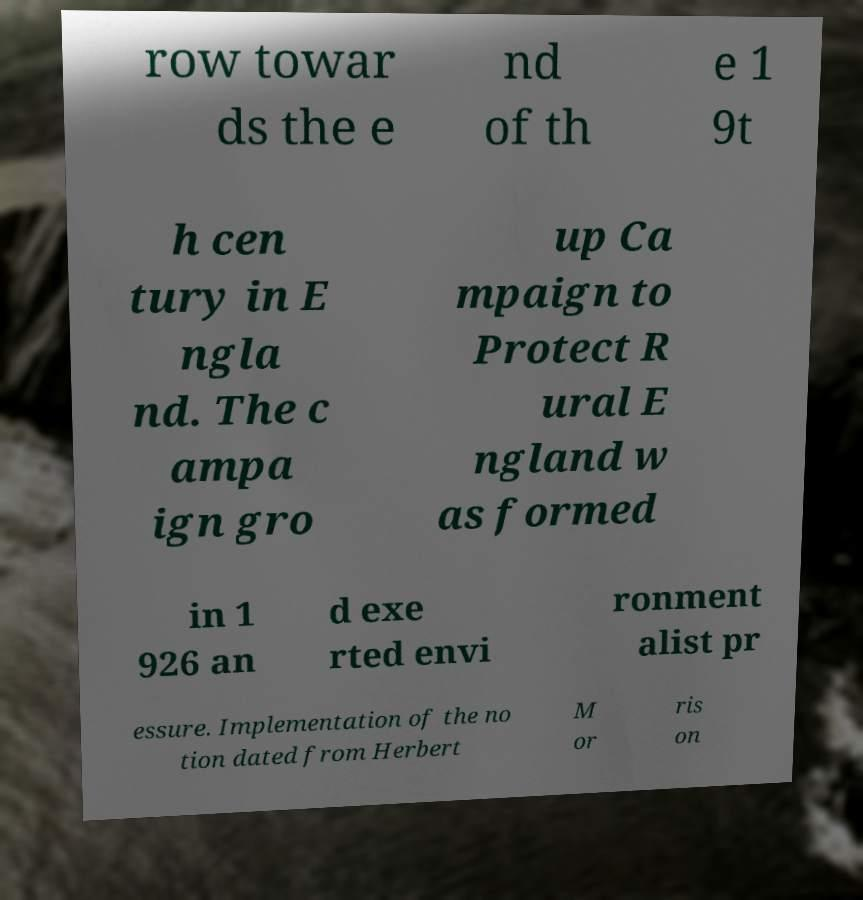Could you extract and type out the text from this image? row towar ds the e nd of th e 1 9t h cen tury in E ngla nd. The c ampa ign gro up Ca mpaign to Protect R ural E ngland w as formed in 1 926 an d exe rted envi ronment alist pr essure. Implementation of the no tion dated from Herbert M or ris on 